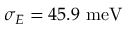<formula> <loc_0><loc_0><loc_500><loc_500>\sigma _ { E } = 4 5 . 9 \ m e V</formula> 